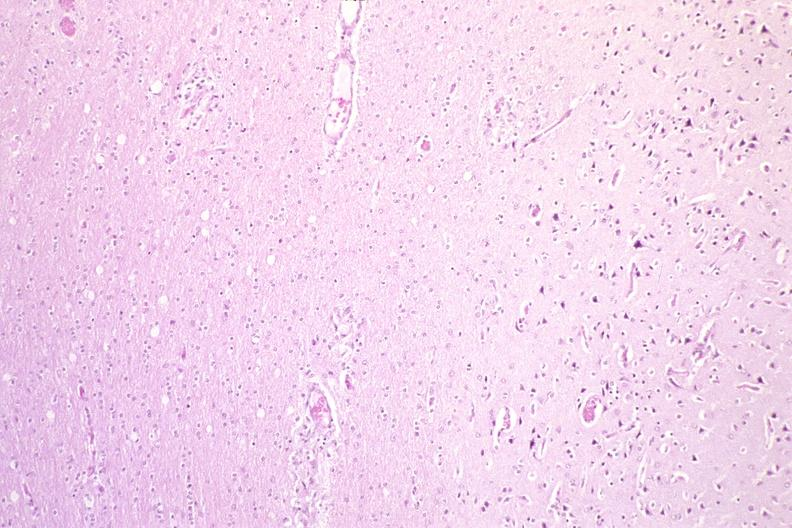s nervous present?
Answer the question using a single word or phrase. Yes 